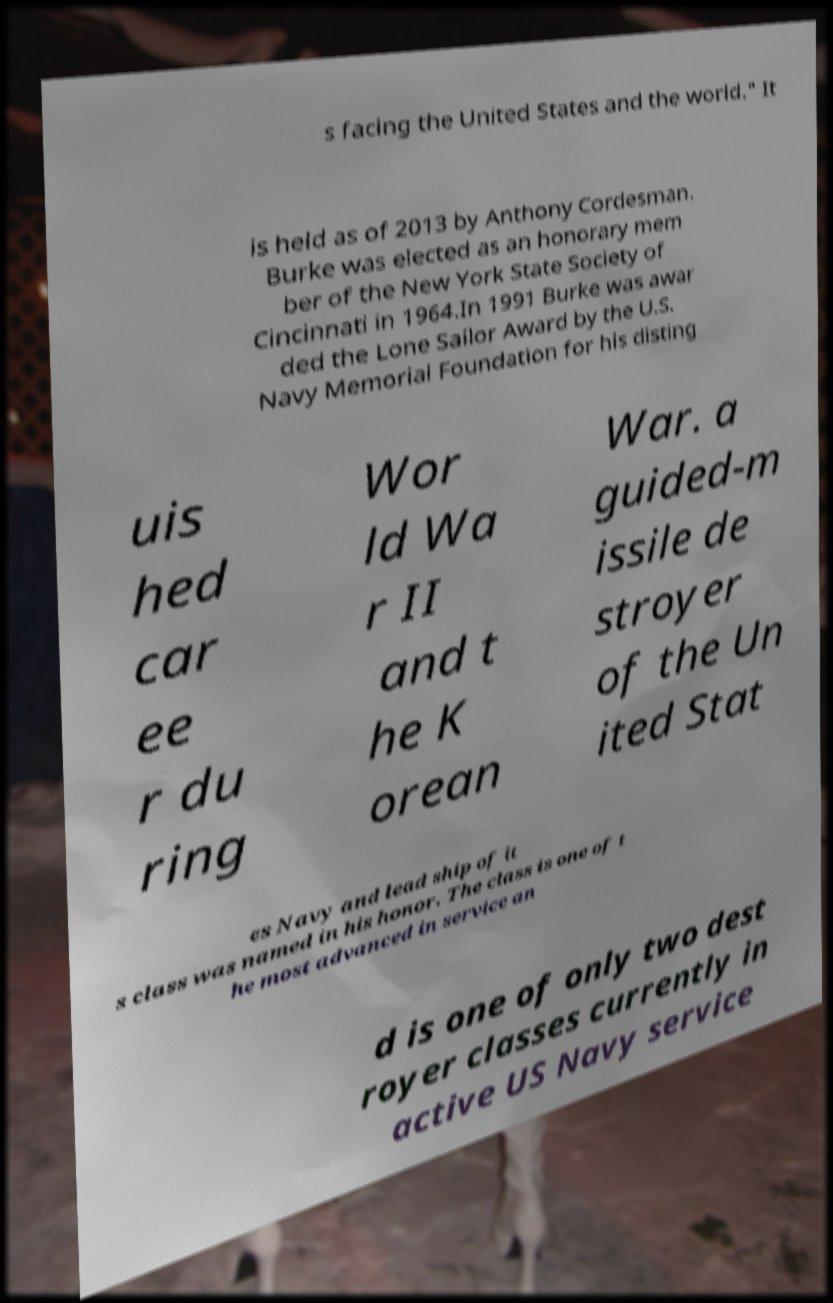I need the written content from this picture converted into text. Can you do that? s facing the United States and the world." It is held as of 2013 by Anthony Cordesman. Burke was elected as an honorary mem ber of the New York State Society of Cincinnati in 1964.In 1991 Burke was awar ded the Lone Sailor Award by the U.S. Navy Memorial Foundation for his disting uis hed car ee r du ring Wor ld Wa r II and t he K orean War. a guided-m issile de stroyer of the Un ited Stat es Navy and lead ship of it s class was named in his honor. The class is one of t he most advanced in service an d is one of only two dest royer classes currently in active US Navy service 